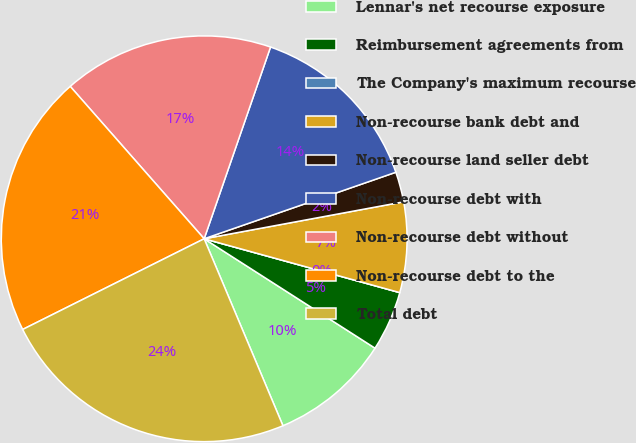Convert chart to OTSL. <chart><loc_0><loc_0><loc_500><loc_500><pie_chart><fcel>Lennar's net recourse exposure<fcel>Reimbursement agreements from<fcel>The Company's maximum recourse<fcel>Non-recourse bank debt and<fcel>Non-recourse land seller debt<fcel>Non-recourse debt with<fcel>Non-recourse debt without<fcel>Non-recourse debt to the<fcel>Total debt<nl><fcel>9.59%<fcel>4.79%<fcel>0.0%<fcel>7.19%<fcel>2.4%<fcel>14.38%<fcel>16.78%<fcel>20.9%<fcel>23.97%<nl></chart> 